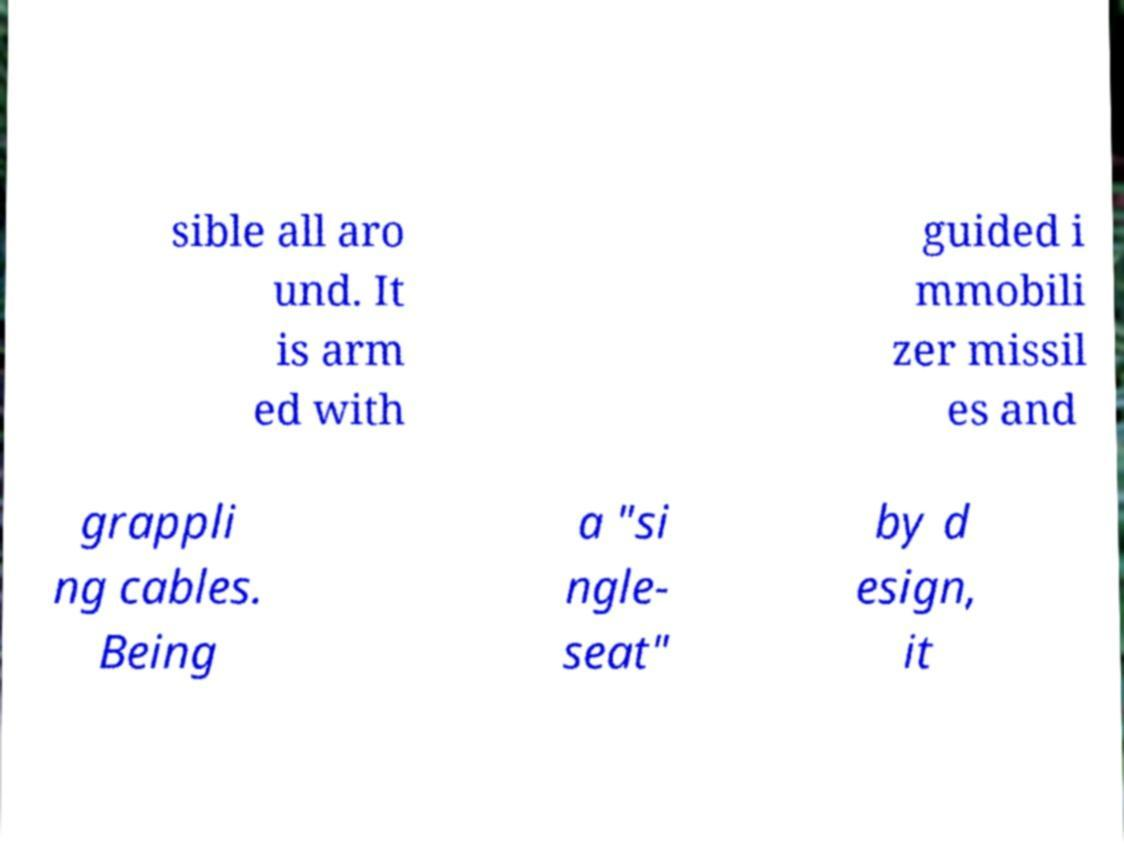Can you read and provide the text displayed in the image?This photo seems to have some interesting text. Can you extract and type it out for me? sible all aro und. It is arm ed with guided i mmobili zer missil es and grappli ng cables. Being a "si ngle- seat" by d esign, it 